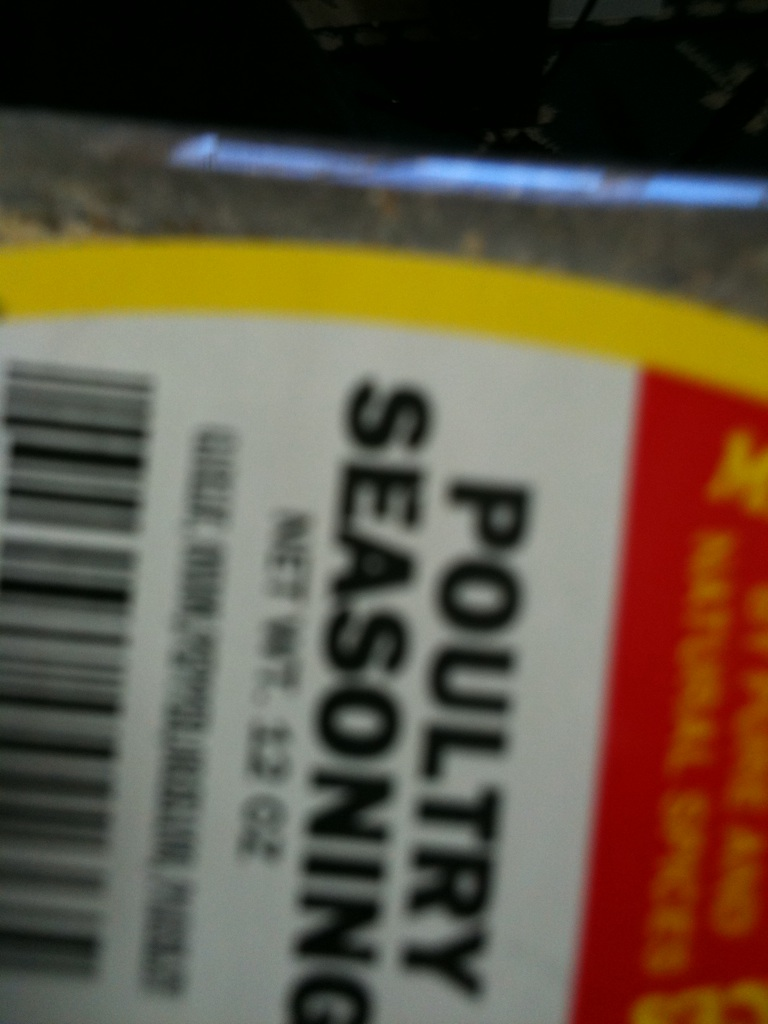What spice is this? from Vizwiz poultry seasoning 